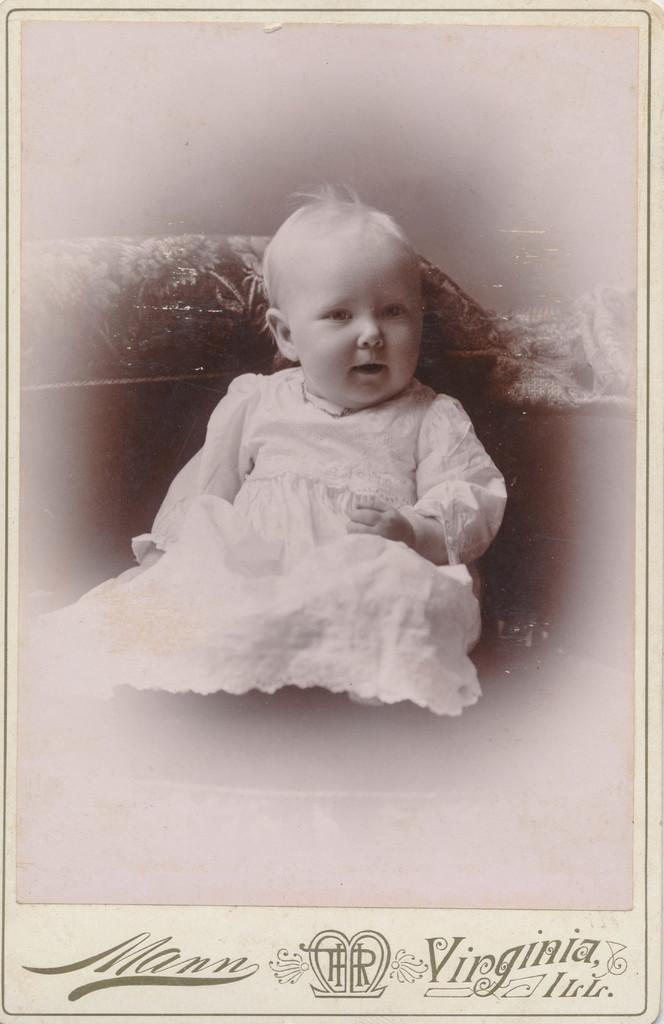What is the main subject of the image? There is a small baby in the image. What is the baby wearing? The baby is wearing a white frock. What position is the baby in? The baby is sitting. Who or what is the baby looking at? The baby is looking at someone. How many ladybugs are crawling on the baby's frock in the image? There are no ladybugs present in the image. What type of line is visible in the image? There is no line visible in the image. 